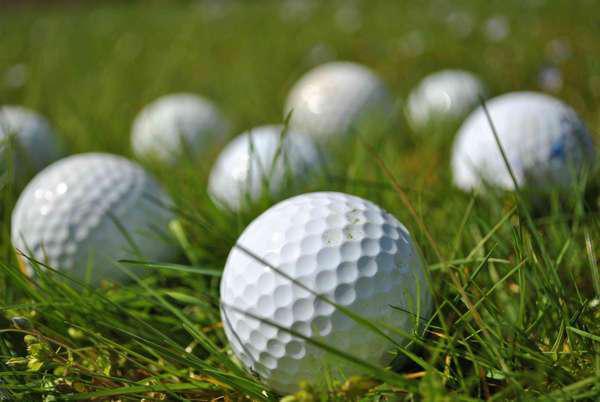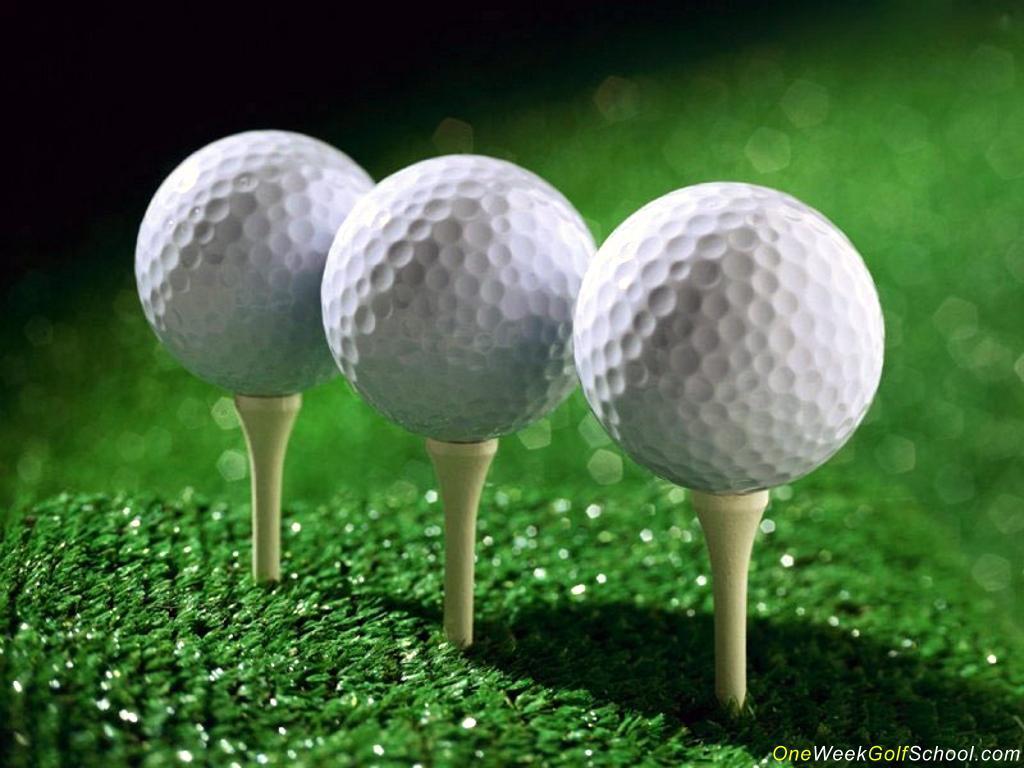The first image is the image on the left, the second image is the image on the right. Examine the images to the left and right. Is the description "In one image, all golf balls are on a tee, and in the other image, no golf balls are on a tee." accurate? Answer yes or no. Yes. 